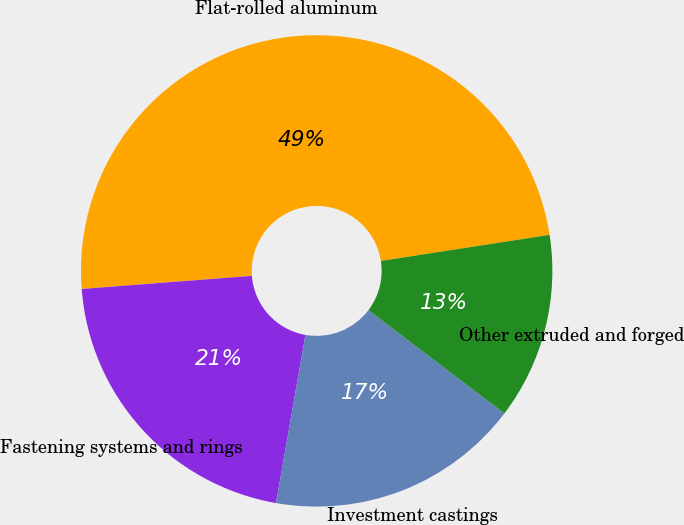<chart> <loc_0><loc_0><loc_500><loc_500><pie_chart><fcel>Flat-rolled aluminum<fcel>Fastening systems and rings<fcel>Investment castings<fcel>Other extruded and forged<nl><fcel>48.78%<fcel>21.02%<fcel>17.42%<fcel>12.78%<nl></chart> 